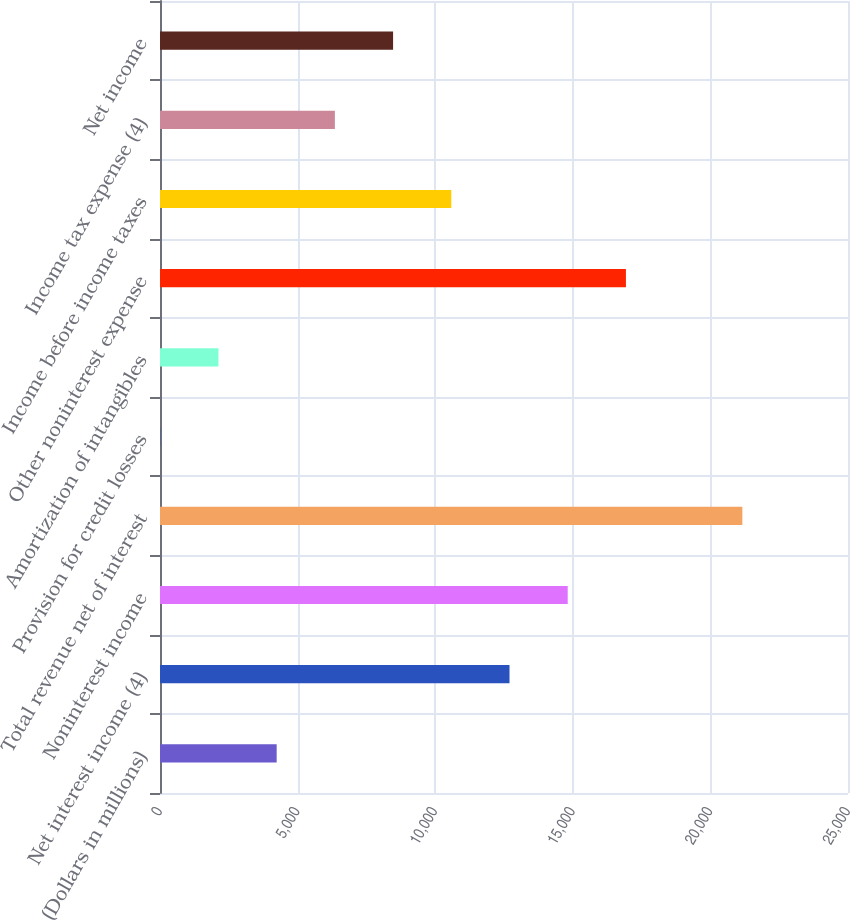Convert chart. <chart><loc_0><loc_0><loc_500><loc_500><bar_chart><fcel>(Dollars in millions)<fcel>Net interest income (4)<fcel>Noninterest income<fcel>Total revenue net of interest<fcel>Provision for credit losses<fcel>Amortization of intangibles<fcel>Other noninterest expense<fcel>Income before income taxes<fcel>Income tax expense (4)<fcel>Net income<nl><fcel>4239.4<fcel>12700.2<fcel>14815.4<fcel>21161<fcel>9<fcel>2124.2<fcel>16930.6<fcel>10585<fcel>6354.6<fcel>8469.8<nl></chart> 